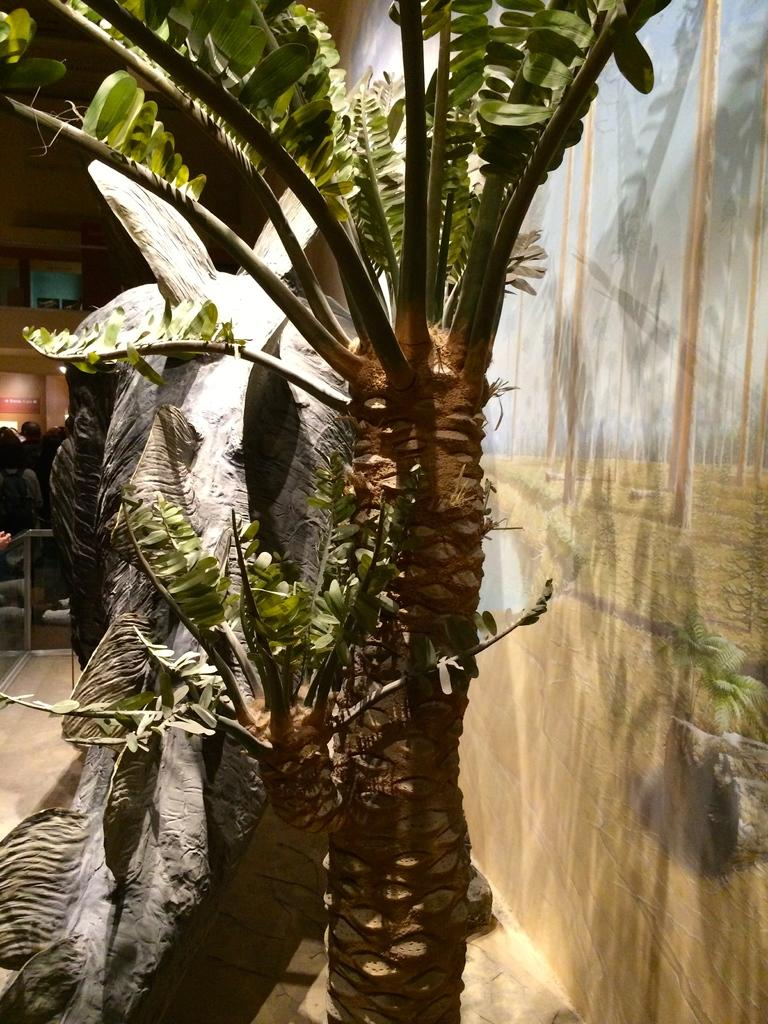What is hanging on the wall in the image? There is a painting on the wall. What is located next to the painting? There is a tree beside the painting. Are there any people visible in the image? Yes, people are visible in the distance. What type of needle is being used to create the painting in the image? There is no needle present in the image, as the painting is already completed and hanging on the wall. What drug might the people in the distance be using in the image? There is no indication of drug use in the image, and it is not appropriate to make assumptions about the people's activities. 